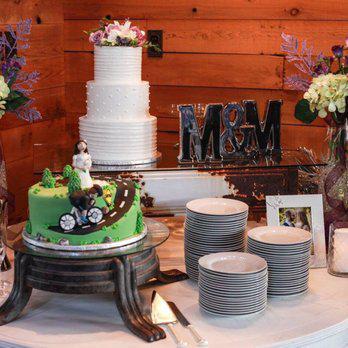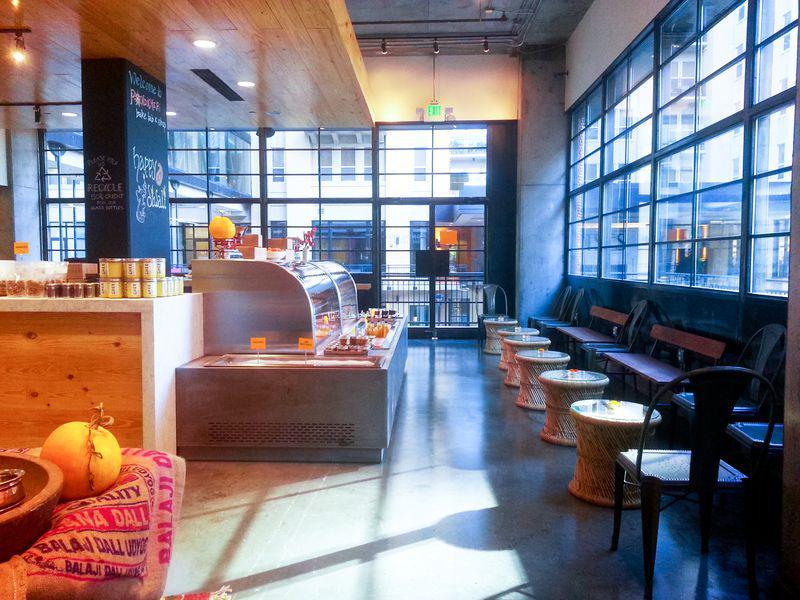The first image is the image on the left, the second image is the image on the right. Considering the images on both sides, is "The left image includes a baked item displayed on a pedestal." valid? Answer yes or no. Yes. 